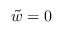<formula> <loc_0><loc_0><loc_500><loc_500>\tilde { w } = 0</formula> 